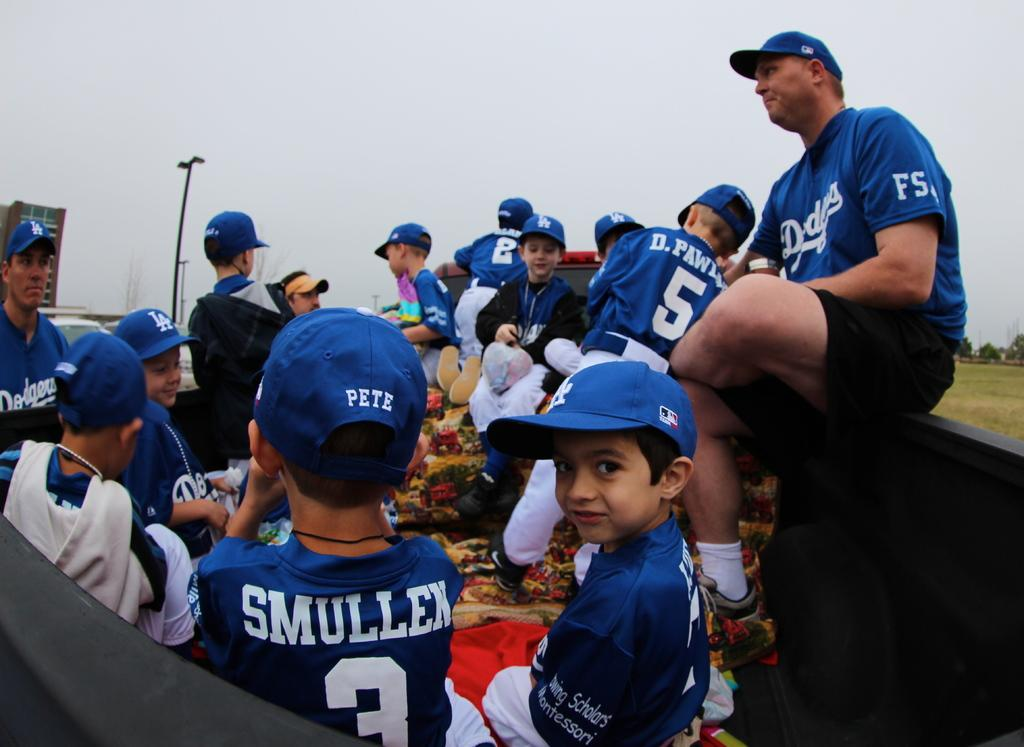<image>
Relay a brief, clear account of the picture shown. A group of young boys wearing Dodger jerseys and caps are hanging around with a couple adults also in Dodger gear. 